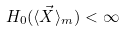<formula> <loc_0><loc_0><loc_500><loc_500>H _ { 0 } ( \langle \vec { X } \rangle _ { m } ) < \infty</formula> 